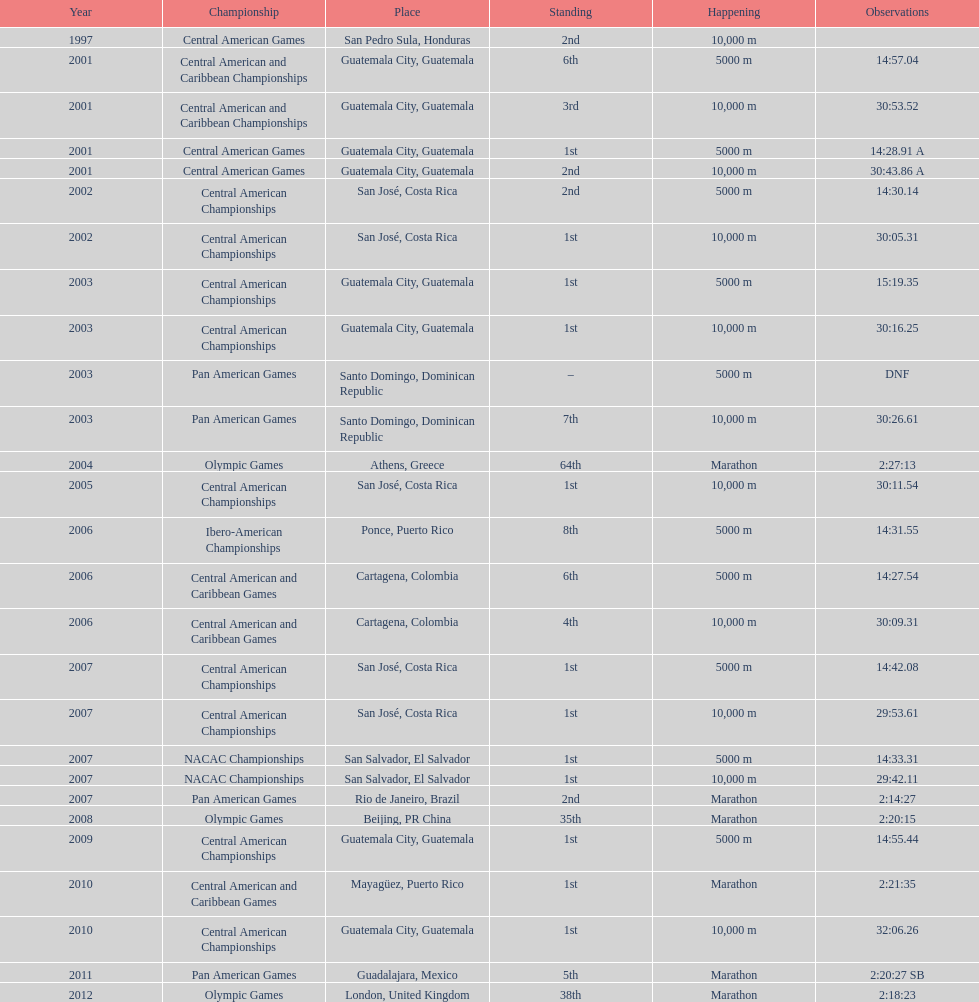Which of each game in 2007 was in the 2nd position? Pan American Games. 